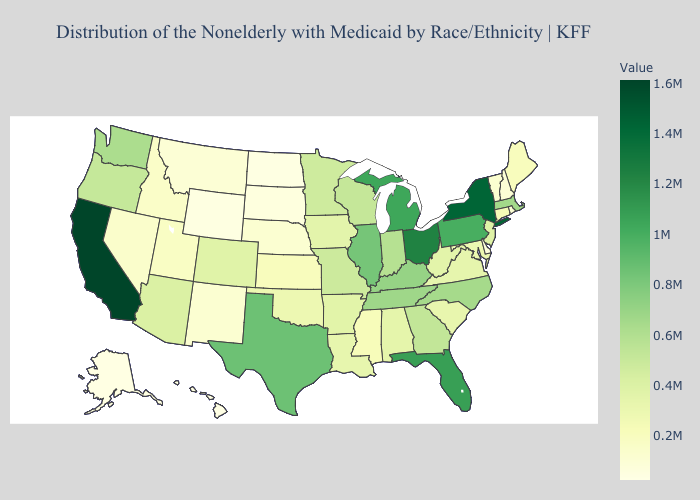Among the states that border Washington , does Oregon have the lowest value?
Quick response, please. No. Does Alaska have a higher value than Michigan?
Short answer required. No. Does the map have missing data?
Short answer required. No. 